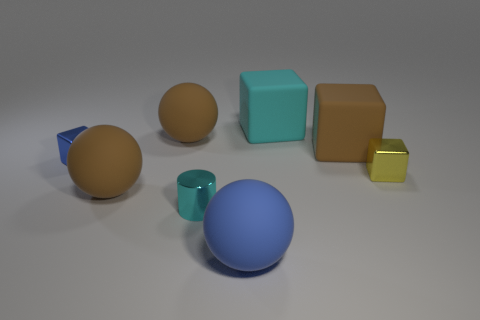Subtract all brown spheres. How many were subtracted if there are1brown spheres left? 1 Subtract all big brown balls. How many balls are left? 1 Add 1 cyan blocks. How many objects exist? 9 Subtract all brown spheres. How many spheres are left? 1 Subtract 2 blocks. How many blocks are left? 2 Subtract all brown cylinders. How many brown cubes are left? 1 Subtract 0 red spheres. How many objects are left? 8 Subtract all balls. How many objects are left? 5 Subtract all yellow spheres. Subtract all yellow cubes. How many spheres are left? 3 Subtract all blue balls. Subtract all cubes. How many objects are left? 3 